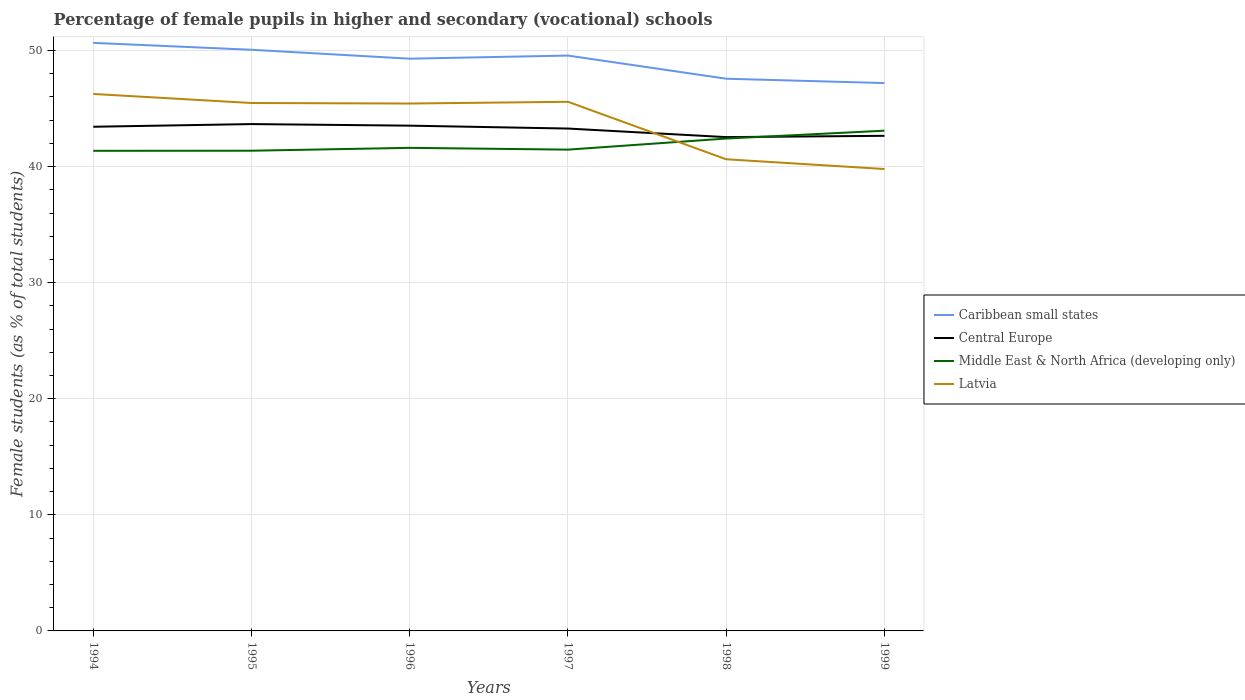Does the line corresponding to Caribbean small states intersect with the line corresponding to Latvia?
Ensure brevity in your answer.  No. Across all years, what is the maximum percentage of female pupils in higher and secondary schools in Middle East & North Africa (developing only)?
Provide a succinct answer. 41.36. In which year was the percentage of female pupils in higher and secondary schools in Caribbean small states maximum?
Your answer should be very brief. 1999. What is the total percentage of female pupils in higher and secondary schools in Caribbean small states in the graph?
Provide a succinct answer. 3.46. What is the difference between the highest and the second highest percentage of female pupils in higher and secondary schools in Latvia?
Provide a short and direct response. 6.47. What is the difference between the highest and the lowest percentage of female pupils in higher and secondary schools in Latvia?
Offer a very short reply. 4. Is the percentage of female pupils in higher and secondary schools in Central Europe strictly greater than the percentage of female pupils in higher and secondary schools in Latvia over the years?
Offer a very short reply. No. How many lines are there?
Offer a very short reply. 4. How many years are there in the graph?
Ensure brevity in your answer.  6. Are the values on the major ticks of Y-axis written in scientific E-notation?
Provide a short and direct response. No. How many legend labels are there?
Offer a terse response. 4. What is the title of the graph?
Offer a very short reply. Percentage of female pupils in higher and secondary (vocational) schools. What is the label or title of the Y-axis?
Ensure brevity in your answer.  Female students (as % of total students). What is the Female students (as % of total students) of Caribbean small states in 1994?
Your answer should be compact. 50.66. What is the Female students (as % of total students) of Central Europe in 1994?
Provide a succinct answer. 43.44. What is the Female students (as % of total students) of Middle East & North Africa (developing only) in 1994?
Your answer should be very brief. 41.36. What is the Female students (as % of total students) in Latvia in 1994?
Provide a succinct answer. 46.26. What is the Female students (as % of total students) of Caribbean small states in 1995?
Ensure brevity in your answer.  50.07. What is the Female students (as % of total students) of Central Europe in 1995?
Ensure brevity in your answer.  43.67. What is the Female students (as % of total students) in Middle East & North Africa (developing only) in 1995?
Provide a short and direct response. 41.37. What is the Female students (as % of total students) of Latvia in 1995?
Make the answer very short. 45.48. What is the Female students (as % of total students) in Caribbean small states in 1996?
Provide a short and direct response. 49.3. What is the Female students (as % of total students) of Central Europe in 1996?
Make the answer very short. 43.53. What is the Female students (as % of total students) in Middle East & North Africa (developing only) in 1996?
Your response must be concise. 41.62. What is the Female students (as % of total students) in Latvia in 1996?
Offer a very short reply. 45.44. What is the Female students (as % of total students) of Caribbean small states in 1997?
Ensure brevity in your answer.  49.57. What is the Female students (as % of total students) in Central Europe in 1997?
Make the answer very short. 43.28. What is the Female students (as % of total students) of Middle East & North Africa (developing only) in 1997?
Offer a terse response. 41.47. What is the Female students (as % of total students) of Latvia in 1997?
Offer a terse response. 45.59. What is the Female students (as % of total students) in Caribbean small states in 1998?
Your answer should be very brief. 47.58. What is the Female students (as % of total students) of Central Europe in 1998?
Give a very brief answer. 42.54. What is the Female students (as % of total students) in Middle East & North Africa (developing only) in 1998?
Give a very brief answer. 42.42. What is the Female students (as % of total students) in Latvia in 1998?
Ensure brevity in your answer.  40.64. What is the Female students (as % of total students) of Caribbean small states in 1999?
Make the answer very short. 47.2. What is the Female students (as % of total students) in Central Europe in 1999?
Keep it short and to the point. 42.66. What is the Female students (as % of total students) of Middle East & North Africa (developing only) in 1999?
Provide a succinct answer. 43.1. What is the Female students (as % of total students) of Latvia in 1999?
Make the answer very short. 39.8. Across all years, what is the maximum Female students (as % of total students) in Caribbean small states?
Your answer should be very brief. 50.66. Across all years, what is the maximum Female students (as % of total students) of Central Europe?
Offer a terse response. 43.67. Across all years, what is the maximum Female students (as % of total students) in Middle East & North Africa (developing only)?
Make the answer very short. 43.1. Across all years, what is the maximum Female students (as % of total students) in Latvia?
Offer a terse response. 46.26. Across all years, what is the minimum Female students (as % of total students) in Caribbean small states?
Keep it short and to the point. 47.2. Across all years, what is the minimum Female students (as % of total students) in Central Europe?
Give a very brief answer. 42.54. Across all years, what is the minimum Female students (as % of total students) in Middle East & North Africa (developing only)?
Keep it short and to the point. 41.36. Across all years, what is the minimum Female students (as % of total students) in Latvia?
Make the answer very short. 39.8. What is the total Female students (as % of total students) of Caribbean small states in the graph?
Your answer should be compact. 294.38. What is the total Female students (as % of total students) in Central Europe in the graph?
Your answer should be compact. 259.12. What is the total Female students (as % of total students) of Middle East & North Africa (developing only) in the graph?
Make the answer very short. 251.34. What is the total Female students (as % of total students) in Latvia in the graph?
Your response must be concise. 263.2. What is the difference between the Female students (as % of total students) of Caribbean small states in 1994 and that in 1995?
Offer a terse response. 0.59. What is the difference between the Female students (as % of total students) of Central Europe in 1994 and that in 1995?
Your answer should be very brief. -0.23. What is the difference between the Female students (as % of total students) in Middle East & North Africa (developing only) in 1994 and that in 1995?
Your answer should be very brief. -0.01. What is the difference between the Female students (as % of total students) of Latvia in 1994 and that in 1995?
Offer a very short reply. 0.78. What is the difference between the Female students (as % of total students) of Caribbean small states in 1994 and that in 1996?
Keep it short and to the point. 1.36. What is the difference between the Female students (as % of total students) of Central Europe in 1994 and that in 1996?
Give a very brief answer. -0.09. What is the difference between the Female students (as % of total students) of Middle East & North Africa (developing only) in 1994 and that in 1996?
Offer a very short reply. -0.25. What is the difference between the Female students (as % of total students) of Latvia in 1994 and that in 1996?
Your response must be concise. 0.83. What is the difference between the Female students (as % of total students) of Caribbean small states in 1994 and that in 1997?
Offer a very short reply. 1.09. What is the difference between the Female students (as % of total students) of Central Europe in 1994 and that in 1997?
Provide a short and direct response. 0.15. What is the difference between the Female students (as % of total students) in Middle East & North Africa (developing only) in 1994 and that in 1997?
Provide a short and direct response. -0.1. What is the difference between the Female students (as % of total students) of Latvia in 1994 and that in 1997?
Make the answer very short. 0.68. What is the difference between the Female students (as % of total students) in Caribbean small states in 1994 and that in 1998?
Offer a terse response. 3.09. What is the difference between the Female students (as % of total students) of Central Europe in 1994 and that in 1998?
Give a very brief answer. 0.89. What is the difference between the Female students (as % of total students) in Middle East & North Africa (developing only) in 1994 and that in 1998?
Make the answer very short. -1.06. What is the difference between the Female students (as % of total students) in Latvia in 1994 and that in 1998?
Your response must be concise. 5.63. What is the difference between the Female students (as % of total students) in Caribbean small states in 1994 and that in 1999?
Provide a succinct answer. 3.46. What is the difference between the Female students (as % of total students) of Central Europe in 1994 and that in 1999?
Keep it short and to the point. 0.78. What is the difference between the Female students (as % of total students) of Middle East & North Africa (developing only) in 1994 and that in 1999?
Keep it short and to the point. -1.73. What is the difference between the Female students (as % of total students) of Latvia in 1994 and that in 1999?
Your answer should be compact. 6.47. What is the difference between the Female students (as % of total students) in Caribbean small states in 1995 and that in 1996?
Give a very brief answer. 0.77. What is the difference between the Female students (as % of total students) of Central Europe in 1995 and that in 1996?
Make the answer very short. 0.14. What is the difference between the Female students (as % of total students) in Middle East & North Africa (developing only) in 1995 and that in 1996?
Your answer should be compact. -0.25. What is the difference between the Female students (as % of total students) of Latvia in 1995 and that in 1996?
Offer a terse response. 0.04. What is the difference between the Female students (as % of total students) of Caribbean small states in 1995 and that in 1997?
Keep it short and to the point. 0.5. What is the difference between the Female students (as % of total students) of Central Europe in 1995 and that in 1997?
Offer a very short reply. 0.38. What is the difference between the Female students (as % of total students) of Middle East & North Africa (developing only) in 1995 and that in 1997?
Give a very brief answer. -0.09. What is the difference between the Female students (as % of total students) in Latvia in 1995 and that in 1997?
Your answer should be very brief. -0.1. What is the difference between the Female students (as % of total students) of Caribbean small states in 1995 and that in 1998?
Keep it short and to the point. 2.49. What is the difference between the Female students (as % of total students) in Central Europe in 1995 and that in 1998?
Ensure brevity in your answer.  1.12. What is the difference between the Female students (as % of total students) in Middle East & North Africa (developing only) in 1995 and that in 1998?
Your response must be concise. -1.05. What is the difference between the Female students (as % of total students) of Latvia in 1995 and that in 1998?
Provide a succinct answer. 4.85. What is the difference between the Female students (as % of total students) of Caribbean small states in 1995 and that in 1999?
Provide a succinct answer. 2.87. What is the difference between the Female students (as % of total students) of Central Europe in 1995 and that in 1999?
Ensure brevity in your answer.  1.01. What is the difference between the Female students (as % of total students) of Middle East & North Africa (developing only) in 1995 and that in 1999?
Your answer should be very brief. -1.73. What is the difference between the Female students (as % of total students) of Latvia in 1995 and that in 1999?
Make the answer very short. 5.69. What is the difference between the Female students (as % of total students) of Caribbean small states in 1996 and that in 1997?
Your response must be concise. -0.27. What is the difference between the Female students (as % of total students) of Central Europe in 1996 and that in 1997?
Make the answer very short. 0.25. What is the difference between the Female students (as % of total students) in Middle East & North Africa (developing only) in 1996 and that in 1997?
Make the answer very short. 0.15. What is the difference between the Female students (as % of total students) of Latvia in 1996 and that in 1997?
Provide a short and direct response. -0.15. What is the difference between the Female students (as % of total students) in Caribbean small states in 1996 and that in 1998?
Offer a terse response. 1.73. What is the difference between the Female students (as % of total students) in Central Europe in 1996 and that in 1998?
Your answer should be very brief. 0.99. What is the difference between the Female students (as % of total students) in Middle East & North Africa (developing only) in 1996 and that in 1998?
Give a very brief answer. -0.8. What is the difference between the Female students (as % of total students) of Latvia in 1996 and that in 1998?
Offer a very short reply. 4.8. What is the difference between the Female students (as % of total students) of Caribbean small states in 1996 and that in 1999?
Make the answer very short. 2.1. What is the difference between the Female students (as % of total students) of Central Europe in 1996 and that in 1999?
Ensure brevity in your answer.  0.87. What is the difference between the Female students (as % of total students) of Middle East & North Africa (developing only) in 1996 and that in 1999?
Offer a very short reply. -1.48. What is the difference between the Female students (as % of total students) of Latvia in 1996 and that in 1999?
Offer a terse response. 5.64. What is the difference between the Female students (as % of total students) of Caribbean small states in 1997 and that in 1998?
Your answer should be compact. 1.99. What is the difference between the Female students (as % of total students) in Central Europe in 1997 and that in 1998?
Your answer should be compact. 0.74. What is the difference between the Female students (as % of total students) of Middle East & North Africa (developing only) in 1997 and that in 1998?
Offer a very short reply. -0.95. What is the difference between the Female students (as % of total students) in Latvia in 1997 and that in 1998?
Provide a short and direct response. 4.95. What is the difference between the Female students (as % of total students) in Caribbean small states in 1997 and that in 1999?
Ensure brevity in your answer.  2.37. What is the difference between the Female students (as % of total students) in Central Europe in 1997 and that in 1999?
Keep it short and to the point. 0.63. What is the difference between the Female students (as % of total students) of Middle East & North Africa (developing only) in 1997 and that in 1999?
Provide a short and direct response. -1.63. What is the difference between the Female students (as % of total students) of Latvia in 1997 and that in 1999?
Make the answer very short. 5.79. What is the difference between the Female students (as % of total students) in Caribbean small states in 1998 and that in 1999?
Ensure brevity in your answer.  0.38. What is the difference between the Female students (as % of total students) of Central Europe in 1998 and that in 1999?
Your response must be concise. -0.11. What is the difference between the Female students (as % of total students) in Middle East & North Africa (developing only) in 1998 and that in 1999?
Offer a terse response. -0.68. What is the difference between the Female students (as % of total students) of Latvia in 1998 and that in 1999?
Provide a short and direct response. 0.84. What is the difference between the Female students (as % of total students) in Caribbean small states in 1994 and the Female students (as % of total students) in Central Europe in 1995?
Your answer should be very brief. 7. What is the difference between the Female students (as % of total students) of Caribbean small states in 1994 and the Female students (as % of total students) of Middle East & North Africa (developing only) in 1995?
Provide a short and direct response. 9.29. What is the difference between the Female students (as % of total students) in Caribbean small states in 1994 and the Female students (as % of total students) in Latvia in 1995?
Give a very brief answer. 5.18. What is the difference between the Female students (as % of total students) of Central Europe in 1994 and the Female students (as % of total students) of Middle East & North Africa (developing only) in 1995?
Keep it short and to the point. 2.06. What is the difference between the Female students (as % of total students) in Central Europe in 1994 and the Female students (as % of total students) in Latvia in 1995?
Offer a terse response. -2.05. What is the difference between the Female students (as % of total students) in Middle East & North Africa (developing only) in 1994 and the Female students (as % of total students) in Latvia in 1995?
Keep it short and to the point. -4.12. What is the difference between the Female students (as % of total students) in Caribbean small states in 1994 and the Female students (as % of total students) in Central Europe in 1996?
Ensure brevity in your answer.  7.13. What is the difference between the Female students (as % of total students) in Caribbean small states in 1994 and the Female students (as % of total students) in Middle East & North Africa (developing only) in 1996?
Provide a succinct answer. 9.04. What is the difference between the Female students (as % of total students) in Caribbean small states in 1994 and the Female students (as % of total students) in Latvia in 1996?
Your answer should be very brief. 5.23. What is the difference between the Female students (as % of total students) in Central Europe in 1994 and the Female students (as % of total students) in Middle East & North Africa (developing only) in 1996?
Your response must be concise. 1.82. What is the difference between the Female students (as % of total students) of Central Europe in 1994 and the Female students (as % of total students) of Latvia in 1996?
Offer a terse response. -2. What is the difference between the Female students (as % of total students) in Middle East & North Africa (developing only) in 1994 and the Female students (as % of total students) in Latvia in 1996?
Provide a short and direct response. -4.07. What is the difference between the Female students (as % of total students) of Caribbean small states in 1994 and the Female students (as % of total students) of Central Europe in 1997?
Your answer should be very brief. 7.38. What is the difference between the Female students (as % of total students) of Caribbean small states in 1994 and the Female students (as % of total students) of Middle East & North Africa (developing only) in 1997?
Give a very brief answer. 9.2. What is the difference between the Female students (as % of total students) of Caribbean small states in 1994 and the Female students (as % of total students) of Latvia in 1997?
Offer a very short reply. 5.08. What is the difference between the Female students (as % of total students) of Central Europe in 1994 and the Female students (as % of total students) of Middle East & North Africa (developing only) in 1997?
Make the answer very short. 1.97. What is the difference between the Female students (as % of total students) of Central Europe in 1994 and the Female students (as % of total students) of Latvia in 1997?
Your answer should be compact. -2.15. What is the difference between the Female students (as % of total students) in Middle East & North Africa (developing only) in 1994 and the Female students (as % of total students) in Latvia in 1997?
Give a very brief answer. -4.22. What is the difference between the Female students (as % of total students) in Caribbean small states in 1994 and the Female students (as % of total students) in Central Europe in 1998?
Make the answer very short. 8.12. What is the difference between the Female students (as % of total students) of Caribbean small states in 1994 and the Female students (as % of total students) of Middle East & North Africa (developing only) in 1998?
Provide a short and direct response. 8.24. What is the difference between the Female students (as % of total students) in Caribbean small states in 1994 and the Female students (as % of total students) in Latvia in 1998?
Ensure brevity in your answer.  10.03. What is the difference between the Female students (as % of total students) in Central Europe in 1994 and the Female students (as % of total students) in Middle East & North Africa (developing only) in 1998?
Give a very brief answer. 1.02. What is the difference between the Female students (as % of total students) in Central Europe in 1994 and the Female students (as % of total students) in Latvia in 1998?
Offer a very short reply. 2.8. What is the difference between the Female students (as % of total students) in Middle East & North Africa (developing only) in 1994 and the Female students (as % of total students) in Latvia in 1998?
Provide a succinct answer. 0.73. What is the difference between the Female students (as % of total students) in Caribbean small states in 1994 and the Female students (as % of total students) in Central Europe in 1999?
Ensure brevity in your answer.  8.01. What is the difference between the Female students (as % of total students) in Caribbean small states in 1994 and the Female students (as % of total students) in Middle East & North Africa (developing only) in 1999?
Ensure brevity in your answer.  7.56. What is the difference between the Female students (as % of total students) of Caribbean small states in 1994 and the Female students (as % of total students) of Latvia in 1999?
Offer a terse response. 10.87. What is the difference between the Female students (as % of total students) in Central Europe in 1994 and the Female students (as % of total students) in Middle East & North Africa (developing only) in 1999?
Keep it short and to the point. 0.34. What is the difference between the Female students (as % of total students) of Central Europe in 1994 and the Female students (as % of total students) of Latvia in 1999?
Ensure brevity in your answer.  3.64. What is the difference between the Female students (as % of total students) in Middle East & North Africa (developing only) in 1994 and the Female students (as % of total students) in Latvia in 1999?
Offer a very short reply. 1.57. What is the difference between the Female students (as % of total students) in Caribbean small states in 1995 and the Female students (as % of total students) in Central Europe in 1996?
Offer a terse response. 6.54. What is the difference between the Female students (as % of total students) of Caribbean small states in 1995 and the Female students (as % of total students) of Middle East & North Africa (developing only) in 1996?
Your answer should be compact. 8.45. What is the difference between the Female students (as % of total students) of Caribbean small states in 1995 and the Female students (as % of total students) of Latvia in 1996?
Provide a succinct answer. 4.63. What is the difference between the Female students (as % of total students) of Central Europe in 1995 and the Female students (as % of total students) of Middle East & North Africa (developing only) in 1996?
Your answer should be very brief. 2.05. What is the difference between the Female students (as % of total students) in Central Europe in 1995 and the Female students (as % of total students) in Latvia in 1996?
Your answer should be very brief. -1.77. What is the difference between the Female students (as % of total students) in Middle East & North Africa (developing only) in 1995 and the Female students (as % of total students) in Latvia in 1996?
Offer a terse response. -4.07. What is the difference between the Female students (as % of total students) of Caribbean small states in 1995 and the Female students (as % of total students) of Central Europe in 1997?
Make the answer very short. 6.79. What is the difference between the Female students (as % of total students) in Caribbean small states in 1995 and the Female students (as % of total students) in Middle East & North Africa (developing only) in 1997?
Offer a very short reply. 8.6. What is the difference between the Female students (as % of total students) of Caribbean small states in 1995 and the Female students (as % of total students) of Latvia in 1997?
Ensure brevity in your answer.  4.48. What is the difference between the Female students (as % of total students) in Central Europe in 1995 and the Female students (as % of total students) in Middle East & North Africa (developing only) in 1997?
Provide a succinct answer. 2.2. What is the difference between the Female students (as % of total students) in Central Europe in 1995 and the Female students (as % of total students) in Latvia in 1997?
Offer a very short reply. -1.92. What is the difference between the Female students (as % of total students) in Middle East & North Africa (developing only) in 1995 and the Female students (as % of total students) in Latvia in 1997?
Ensure brevity in your answer.  -4.22. What is the difference between the Female students (as % of total students) of Caribbean small states in 1995 and the Female students (as % of total students) of Central Europe in 1998?
Make the answer very short. 7.53. What is the difference between the Female students (as % of total students) in Caribbean small states in 1995 and the Female students (as % of total students) in Middle East & North Africa (developing only) in 1998?
Make the answer very short. 7.65. What is the difference between the Female students (as % of total students) of Caribbean small states in 1995 and the Female students (as % of total students) of Latvia in 1998?
Ensure brevity in your answer.  9.43. What is the difference between the Female students (as % of total students) in Central Europe in 1995 and the Female students (as % of total students) in Middle East & North Africa (developing only) in 1998?
Your answer should be compact. 1.25. What is the difference between the Female students (as % of total students) in Central Europe in 1995 and the Female students (as % of total students) in Latvia in 1998?
Offer a very short reply. 3.03. What is the difference between the Female students (as % of total students) in Middle East & North Africa (developing only) in 1995 and the Female students (as % of total students) in Latvia in 1998?
Provide a short and direct response. 0.74. What is the difference between the Female students (as % of total students) in Caribbean small states in 1995 and the Female students (as % of total students) in Central Europe in 1999?
Your answer should be very brief. 7.41. What is the difference between the Female students (as % of total students) in Caribbean small states in 1995 and the Female students (as % of total students) in Middle East & North Africa (developing only) in 1999?
Offer a terse response. 6.97. What is the difference between the Female students (as % of total students) in Caribbean small states in 1995 and the Female students (as % of total students) in Latvia in 1999?
Ensure brevity in your answer.  10.27. What is the difference between the Female students (as % of total students) in Central Europe in 1995 and the Female students (as % of total students) in Middle East & North Africa (developing only) in 1999?
Provide a short and direct response. 0.57. What is the difference between the Female students (as % of total students) in Central Europe in 1995 and the Female students (as % of total students) in Latvia in 1999?
Your answer should be very brief. 3.87. What is the difference between the Female students (as % of total students) of Middle East & North Africa (developing only) in 1995 and the Female students (as % of total students) of Latvia in 1999?
Give a very brief answer. 1.58. What is the difference between the Female students (as % of total students) of Caribbean small states in 1996 and the Female students (as % of total students) of Central Europe in 1997?
Your response must be concise. 6.02. What is the difference between the Female students (as % of total students) of Caribbean small states in 1996 and the Female students (as % of total students) of Middle East & North Africa (developing only) in 1997?
Give a very brief answer. 7.84. What is the difference between the Female students (as % of total students) of Caribbean small states in 1996 and the Female students (as % of total students) of Latvia in 1997?
Give a very brief answer. 3.71. What is the difference between the Female students (as % of total students) in Central Europe in 1996 and the Female students (as % of total students) in Middle East & North Africa (developing only) in 1997?
Offer a very short reply. 2.07. What is the difference between the Female students (as % of total students) of Central Europe in 1996 and the Female students (as % of total students) of Latvia in 1997?
Offer a very short reply. -2.06. What is the difference between the Female students (as % of total students) of Middle East & North Africa (developing only) in 1996 and the Female students (as % of total students) of Latvia in 1997?
Your answer should be compact. -3.97. What is the difference between the Female students (as % of total students) of Caribbean small states in 1996 and the Female students (as % of total students) of Central Europe in 1998?
Ensure brevity in your answer.  6.76. What is the difference between the Female students (as % of total students) of Caribbean small states in 1996 and the Female students (as % of total students) of Middle East & North Africa (developing only) in 1998?
Provide a succinct answer. 6.88. What is the difference between the Female students (as % of total students) in Caribbean small states in 1996 and the Female students (as % of total students) in Latvia in 1998?
Offer a very short reply. 8.67. What is the difference between the Female students (as % of total students) in Central Europe in 1996 and the Female students (as % of total students) in Middle East & North Africa (developing only) in 1998?
Your answer should be very brief. 1.11. What is the difference between the Female students (as % of total students) in Central Europe in 1996 and the Female students (as % of total students) in Latvia in 1998?
Your answer should be compact. 2.9. What is the difference between the Female students (as % of total students) of Middle East & North Africa (developing only) in 1996 and the Female students (as % of total students) of Latvia in 1998?
Ensure brevity in your answer.  0.98. What is the difference between the Female students (as % of total students) of Caribbean small states in 1996 and the Female students (as % of total students) of Central Europe in 1999?
Provide a succinct answer. 6.65. What is the difference between the Female students (as % of total students) of Caribbean small states in 1996 and the Female students (as % of total students) of Middle East & North Africa (developing only) in 1999?
Offer a terse response. 6.2. What is the difference between the Female students (as % of total students) in Caribbean small states in 1996 and the Female students (as % of total students) in Latvia in 1999?
Give a very brief answer. 9.51. What is the difference between the Female students (as % of total students) in Central Europe in 1996 and the Female students (as % of total students) in Middle East & North Africa (developing only) in 1999?
Ensure brevity in your answer.  0.43. What is the difference between the Female students (as % of total students) of Central Europe in 1996 and the Female students (as % of total students) of Latvia in 1999?
Make the answer very short. 3.74. What is the difference between the Female students (as % of total students) in Middle East & North Africa (developing only) in 1996 and the Female students (as % of total students) in Latvia in 1999?
Your response must be concise. 1.82. What is the difference between the Female students (as % of total students) of Caribbean small states in 1997 and the Female students (as % of total students) of Central Europe in 1998?
Offer a very short reply. 7.03. What is the difference between the Female students (as % of total students) of Caribbean small states in 1997 and the Female students (as % of total students) of Middle East & North Africa (developing only) in 1998?
Your response must be concise. 7.15. What is the difference between the Female students (as % of total students) in Caribbean small states in 1997 and the Female students (as % of total students) in Latvia in 1998?
Offer a very short reply. 8.93. What is the difference between the Female students (as % of total students) in Central Europe in 1997 and the Female students (as % of total students) in Middle East & North Africa (developing only) in 1998?
Offer a very short reply. 0.86. What is the difference between the Female students (as % of total students) of Central Europe in 1997 and the Female students (as % of total students) of Latvia in 1998?
Offer a terse response. 2.65. What is the difference between the Female students (as % of total students) in Middle East & North Africa (developing only) in 1997 and the Female students (as % of total students) in Latvia in 1998?
Offer a terse response. 0.83. What is the difference between the Female students (as % of total students) in Caribbean small states in 1997 and the Female students (as % of total students) in Central Europe in 1999?
Provide a short and direct response. 6.91. What is the difference between the Female students (as % of total students) of Caribbean small states in 1997 and the Female students (as % of total students) of Middle East & North Africa (developing only) in 1999?
Provide a succinct answer. 6.47. What is the difference between the Female students (as % of total students) in Caribbean small states in 1997 and the Female students (as % of total students) in Latvia in 1999?
Offer a very short reply. 9.77. What is the difference between the Female students (as % of total students) in Central Europe in 1997 and the Female students (as % of total students) in Middle East & North Africa (developing only) in 1999?
Ensure brevity in your answer.  0.18. What is the difference between the Female students (as % of total students) of Central Europe in 1997 and the Female students (as % of total students) of Latvia in 1999?
Your answer should be compact. 3.49. What is the difference between the Female students (as % of total students) of Middle East & North Africa (developing only) in 1997 and the Female students (as % of total students) of Latvia in 1999?
Give a very brief answer. 1.67. What is the difference between the Female students (as % of total students) in Caribbean small states in 1998 and the Female students (as % of total students) in Central Europe in 1999?
Give a very brief answer. 4.92. What is the difference between the Female students (as % of total students) of Caribbean small states in 1998 and the Female students (as % of total students) of Middle East & North Africa (developing only) in 1999?
Your answer should be very brief. 4.48. What is the difference between the Female students (as % of total students) in Caribbean small states in 1998 and the Female students (as % of total students) in Latvia in 1999?
Provide a succinct answer. 7.78. What is the difference between the Female students (as % of total students) in Central Europe in 1998 and the Female students (as % of total students) in Middle East & North Africa (developing only) in 1999?
Your response must be concise. -0.55. What is the difference between the Female students (as % of total students) in Central Europe in 1998 and the Female students (as % of total students) in Latvia in 1999?
Keep it short and to the point. 2.75. What is the difference between the Female students (as % of total students) of Middle East & North Africa (developing only) in 1998 and the Female students (as % of total students) of Latvia in 1999?
Make the answer very short. 2.62. What is the average Female students (as % of total students) of Caribbean small states per year?
Give a very brief answer. 49.06. What is the average Female students (as % of total students) of Central Europe per year?
Provide a short and direct response. 43.19. What is the average Female students (as % of total students) in Middle East & North Africa (developing only) per year?
Offer a terse response. 41.89. What is the average Female students (as % of total students) of Latvia per year?
Your response must be concise. 43.87. In the year 1994, what is the difference between the Female students (as % of total students) in Caribbean small states and Female students (as % of total students) in Central Europe?
Offer a terse response. 7.23. In the year 1994, what is the difference between the Female students (as % of total students) of Caribbean small states and Female students (as % of total students) of Middle East & North Africa (developing only)?
Keep it short and to the point. 9.3. In the year 1994, what is the difference between the Female students (as % of total students) in Caribbean small states and Female students (as % of total students) in Latvia?
Offer a terse response. 4.4. In the year 1994, what is the difference between the Female students (as % of total students) in Central Europe and Female students (as % of total students) in Middle East & North Africa (developing only)?
Provide a short and direct response. 2.07. In the year 1994, what is the difference between the Female students (as % of total students) in Central Europe and Female students (as % of total students) in Latvia?
Make the answer very short. -2.83. In the year 1994, what is the difference between the Female students (as % of total students) in Middle East & North Africa (developing only) and Female students (as % of total students) in Latvia?
Provide a succinct answer. -4.9. In the year 1995, what is the difference between the Female students (as % of total students) of Caribbean small states and Female students (as % of total students) of Central Europe?
Make the answer very short. 6.4. In the year 1995, what is the difference between the Female students (as % of total students) of Caribbean small states and Female students (as % of total students) of Middle East & North Africa (developing only)?
Provide a succinct answer. 8.7. In the year 1995, what is the difference between the Female students (as % of total students) of Caribbean small states and Female students (as % of total students) of Latvia?
Ensure brevity in your answer.  4.59. In the year 1995, what is the difference between the Female students (as % of total students) in Central Europe and Female students (as % of total students) in Middle East & North Africa (developing only)?
Provide a succinct answer. 2.29. In the year 1995, what is the difference between the Female students (as % of total students) of Central Europe and Female students (as % of total students) of Latvia?
Your response must be concise. -1.82. In the year 1995, what is the difference between the Female students (as % of total students) in Middle East & North Africa (developing only) and Female students (as % of total students) in Latvia?
Give a very brief answer. -4.11. In the year 1996, what is the difference between the Female students (as % of total students) of Caribbean small states and Female students (as % of total students) of Central Europe?
Your response must be concise. 5.77. In the year 1996, what is the difference between the Female students (as % of total students) in Caribbean small states and Female students (as % of total students) in Middle East & North Africa (developing only)?
Your answer should be very brief. 7.68. In the year 1996, what is the difference between the Female students (as % of total students) of Caribbean small states and Female students (as % of total students) of Latvia?
Your answer should be very brief. 3.86. In the year 1996, what is the difference between the Female students (as % of total students) in Central Europe and Female students (as % of total students) in Middle East & North Africa (developing only)?
Offer a very short reply. 1.91. In the year 1996, what is the difference between the Female students (as % of total students) in Central Europe and Female students (as % of total students) in Latvia?
Your answer should be compact. -1.91. In the year 1996, what is the difference between the Female students (as % of total students) of Middle East & North Africa (developing only) and Female students (as % of total students) of Latvia?
Provide a short and direct response. -3.82. In the year 1997, what is the difference between the Female students (as % of total students) in Caribbean small states and Female students (as % of total students) in Central Europe?
Offer a terse response. 6.29. In the year 1997, what is the difference between the Female students (as % of total students) in Caribbean small states and Female students (as % of total students) in Middle East & North Africa (developing only)?
Offer a terse response. 8.1. In the year 1997, what is the difference between the Female students (as % of total students) in Caribbean small states and Female students (as % of total students) in Latvia?
Make the answer very short. 3.98. In the year 1997, what is the difference between the Female students (as % of total students) in Central Europe and Female students (as % of total students) in Middle East & North Africa (developing only)?
Your answer should be very brief. 1.82. In the year 1997, what is the difference between the Female students (as % of total students) of Central Europe and Female students (as % of total students) of Latvia?
Provide a short and direct response. -2.31. In the year 1997, what is the difference between the Female students (as % of total students) in Middle East & North Africa (developing only) and Female students (as % of total students) in Latvia?
Your answer should be compact. -4.12. In the year 1998, what is the difference between the Female students (as % of total students) of Caribbean small states and Female students (as % of total students) of Central Europe?
Your response must be concise. 5.03. In the year 1998, what is the difference between the Female students (as % of total students) in Caribbean small states and Female students (as % of total students) in Middle East & North Africa (developing only)?
Give a very brief answer. 5.16. In the year 1998, what is the difference between the Female students (as % of total students) of Caribbean small states and Female students (as % of total students) of Latvia?
Make the answer very short. 6.94. In the year 1998, what is the difference between the Female students (as % of total students) of Central Europe and Female students (as % of total students) of Middle East & North Africa (developing only)?
Offer a very short reply. 0.12. In the year 1998, what is the difference between the Female students (as % of total students) in Central Europe and Female students (as % of total students) in Latvia?
Ensure brevity in your answer.  1.91. In the year 1998, what is the difference between the Female students (as % of total students) of Middle East & North Africa (developing only) and Female students (as % of total students) of Latvia?
Your answer should be compact. 1.78. In the year 1999, what is the difference between the Female students (as % of total students) of Caribbean small states and Female students (as % of total students) of Central Europe?
Offer a terse response. 4.54. In the year 1999, what is the difference between the Female students (as % of total students) of Caribbean small states and Female students (as % of total students) of Middle East & North Africa (developing only)?
Your answer should be very brief. 4.1. In the year 1999, what is the difference between the Female students (as % of total students) of Caribbean small states and Female students (as % of total students) of Latvia?
Make the answer very short. 7.4. In the year 1999, what is the difference between the Female students (as % of total students) of Central Europe and Female students (as % of total students) of Middle East & North Africa (developing only)?
Your answer should be compact. -0.44. In the year 1999, what is the difference between the Female students (as % of total students) of Central Europe and Female students (as % of total students) of Latvia?
Offer a terse response. 2.86. In the year 1999, what is the difference between the Female students (as % of total students) of Middle East & North Africa (developing only) and Female students (as % of total students) of Latvia?
Provide a short and direct response. 3.3. What is the ratio of the Female students (as % of total students) in Caribbean small states in 1994 to that in 1995?
Your answer should be very brief. 1.01. What is the ratio of the Female students (as % of total students) of Middle East & North Africa (developing only) in 1994 to that in 1995?
Give a very brief answer. 1. What is the ratio of the Female students (as % of total students) in Latvia in 1994 to that in 1995?
Offer a very short reply. 1.02. What is the ratio of the Female students (as % of total students) of Caribbean small states in 1994 to that in 1996?
Your answer should be compact. 1.03. What is the ratio of the Female students (as % of total students) in Middle East & North Africa (developing only) in 1994 to that in 1996?
Give a very brief answer. 0.99. What is the ratio of the Female students (as % of total students) of Latvia in 1994 to that in 1996?
Keep it short and to the point. 1.02. What is the ratio of the Female students (as % of total students) in Caribbean small states in 1994 to that in 1997?
Keep it short and to the point. 1.02. What is the ratio of the Female students (as % of total students) of Latvia in 1994 to that in 1997?
Keep it short and to the point. 1.01. What is the ratio of the Female students (as % of total students) in Caribbean small states in 1994 to that in 1998?
Ensure brevity in your answer.  1.06. What is the ratio of the Female students (as % of total students) of Central Europe in 1994 to that in 1998?
Offer a terse response. 1.02. What is the ratio of the Female students (as % of total students) of Middle East & North Africa (developing only) in 1994 to that in 1998?
Your answer should be compact. 0.98. What is the ratio of the Female students (as % of total students) in Latvia in 1994 to that in 1998?
Keep it short and to the point. 1.14. What is the ratio of the Female students (as % of total students) of Caribbean small states in 1994 to that in 1999?
Keep it short and to the point. 1.07. What is the ratio of the Female students (as % of total students) of Central Europe in 1994 to that in 1999?
Offer a terse response. 1.02. What is the ratio of the Female students (as % of total students) of Middle East & North Africa (developing only) in 1994 to that in 1999?
Your answer should be compact. 0.96. What is the ratio of the Female students (as % of total students) of Latvia in 1994 to that in 1999?
Offer a very short reply. 1.16. What is the ratio of the Female students (as % of total students) of Caribbean small states in 1995 to that in 1996?
Offer a terse response. 1.02. What is the ratio of the Female students (as % of total students) in Central Europe in 1995 to that in 1996?
Keep it short and to the point. 1. What is the ratio of the Female students (as % of total students) of Middle East & North Africa (developing only) in 1995 to that in 1996?
Offer a terse response. 0.99. What is the ratio of the Female students (as % of total students) in Latvia in 1995 to that in 1996?
Give a very brief answer. 1. What is the ratio of the Female students (as % of total students) of Caribbean small states in 1995 to that in 1997?
Your response must be concise. 1.01. What is the ratio of the Female students (as % of total students) of Central Europe in 1995 to that in 1997?
Your response must be concise. 1.01. What is the ratio of the Female students (as % of total students) of Latvia in 1995 to that in 1997?
Offer a terse response. 1. What is the ratio of the Female students (as % of total students) of Caribbean small states in 1995 to that in 1998?
Give a very brief answer. 1.05. What is the ratio of the Female students (as % of total students) of Central Europe in 1995 to that in 1998?
Give a very brief answer. 1.03. What is the ratio of the Female students (as % of total students) in Middle East & North Africa (developing only) in 1995 to that in 1998?
Your answer should be compact. 0.98. What is the ratio of the Female students (as % of total students) in Latvia in 1995 to that in 1998?
Provide a succinct answer. 1.12. What is the ratio of the Female students (as % of total students) in Caribbean small states in 1995 to that in 1999?
Make the answer very short. 1.06. What is the ratio of the Female students (as % of total students) of Central Europe in 1995 to that in 1999?
Your answer should be compact. 1.02. What is the ratio of the Female students (as % of total students) in Caribbean small states in 1996 to that in 1997?
Your answer should be very brief. 0.99. What is the ratio of the Female students (as % of total students) in Central Europe in 1996 to that in 1997?
Your answer should be very brief. 1.01. What is the ratio of the Female students (as % of total students) in Middle East & North Africa (developing only) in 1996 to that in 1997?
Offer a terse response. 1. What is the ratio of the Female students (as % of total students) of Caribbean small states in 1996 to that in 1998?
Your answer should be compact. 1.04. What is the ratio of the Female students (as % of total students) in Central Europe in 1996 to that in 1998?
Give a very brief answer. 1.02. What is the ratio of the Female students (as % of total students) in Middle East & North Africa (developing only) in 1996 to that in 1998?
Keep it short and to the point. 0.98. What is the ratio of the Female students (as % of total students) of Latvia in 1996 to that in 1998?
Make the answer very short. 1.12. What is the ratio of the Female students (as % of total students) of Caribbean small states in 1996 to that in 1999?
Offer a terse response. 1.04. What is the ratio of the Female students (as % of total students) of Central Europe in 1996 to that in 1999?
Your response must be concise. 1.02. What is the ratio of the Female students (as % of total students) in Middle East & North Africa (developing only) in 1996 to that in 1999?
Your answer should be very brief. 0.97. What is the ratio of the Female students (as % of total students) in Latvia in 1996 to that in 1999?
Make the answer very short. 1.14. What is the ratio of the Female students (as % of total students) in Caribbean small states in 1997 to that in 1998?
Make the answer very short. 1.04. What is the ratio of the Female students (as % of total students) of Central Europe in 1997 to that in 1998?
Keep it short and to the point. 1.02. What is the ratio of the Female students (as % of total students) in Middle East & North Africa (developing only) in 1997 to that in 1998?
Offer a very short reply. 0.98. What is the ratio of the Female students (as % of total students) of Latvia in 1997 to that in 1998?
Your answer should be very brief. 1.12. What is the ratio of the Female students (as % of total students) in Caribbean small states in 1997 to that in 1999?
Provide a short and direct response. 1.05. What is the ratio of the Female students (as % of total students) in Central Europe in 1997 to that in 1999?
Offer a terse response. 1.01. What is the ratio of the Female students (as % of total students) of Middle East & North Africa (developing only) in 1997 to that in 1999?
Ensure brevity in your answer.  0.96. What is the ratio of the Female students (as % of total students) of Latvia in 1997 to that in 1999?
Give a very brief answer. 1.15. What is the ratio of the Female students (as % of total students) in Central Europe in 1998 to that in 1999?
Offer a terse response. 1. What is the ratio of the Female students (as % of total students) of Middle East & North Africa (developing only) in 1998 to that in 1999?
Your answer should be very brief. 0.98. What is the ratio of the Female students (as % of total students) in Latvia in 1998 to that in 1999?
Provide a short and direct response. 1.02. What is the difference between the highest and the second highest Female students (as % of total students) of Caribbean small states?
Your response must be concise. 0.59. What is the difference between the highest and the second highest Female students (as % of total students) of Central Europe?
Your answer should be very brief. 0.14. What is the difference between the highest and the second highest Female students (as % of total students) in Middle East & North Africa (developing only)?
Offer a very short reply. 0.68. What is the difference between the highest and the second highest Female students (as % of total students) of Latvia?
Offer a very short reply. 0.68. What is the difference between the highest and the lowest Female students (as % of total students) of Caribbean small states?
Offer a terse response. 3.46. What is the difference between the highest and the lowest Female students (as % of total students) of Central Europe?
Make the answer very short. 1.12. What is the difference between the highest and the lowest Female students (as % of total students) of Middle East & North Africa (developing only)?
Provide a short and direct response. 1.73. What is the difference between the highest and the lowest Female students (as % of total students) of Latvia?
Your response must be concise. 6.47. 